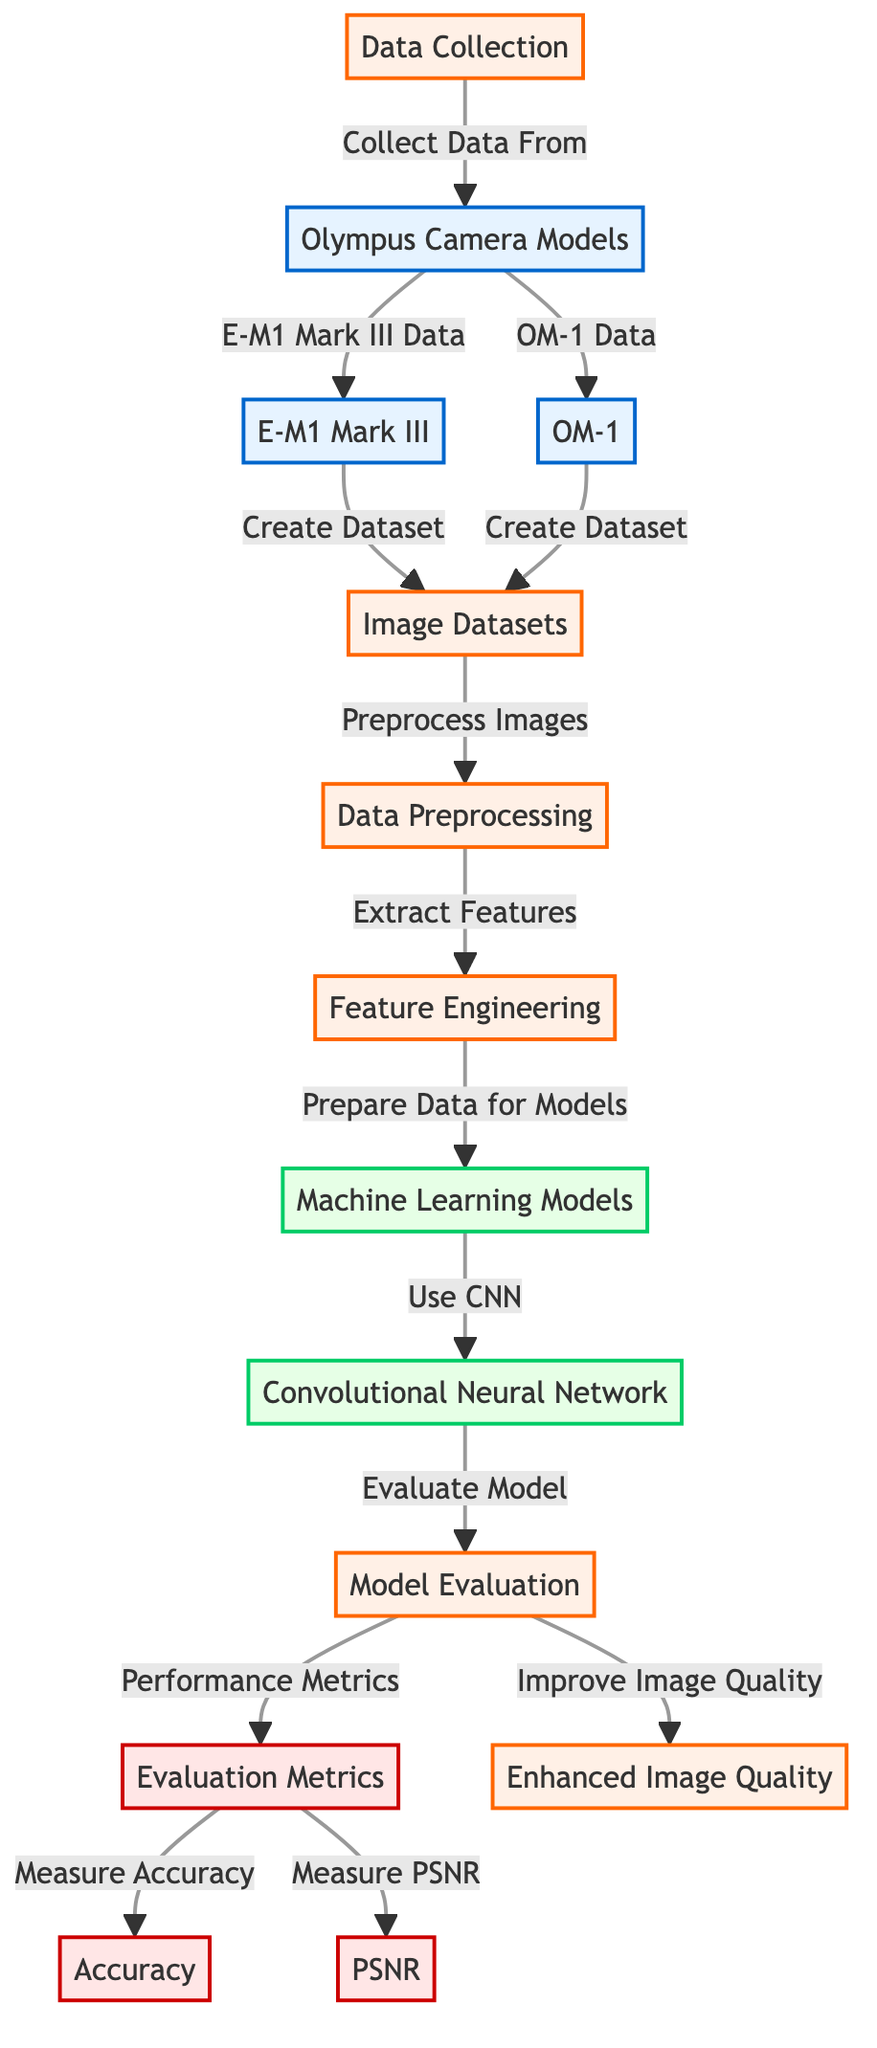What are the two Olympus camera models used in this analysis? The diagram explicitly lists "E-M1 Mark III" and "OM-1" under the "Olympus Camera Models" node.
Answer: E-M1 Mark III, OM-1 What is the first step in the process of the diagram? The first node listed in the process is "Data Collection," indicating that data is to be collected before any other process can take place.
Answer: Data Collection How many evaluation metrics are used in the model evaluation stage? The diagram shows two metrics: "Accuracy" and "PSNR" under the "Evaluation Metrics" node, indicating that these metrics are used to evaluate the model's performance.
Answer: Two What is the direct relationship between "Image Datasets" and "Data Preprocessing"? "Image Datasets" connects to "Data Preprocessing," indicating that the images collected from the various camera models are then subjected to preprocessing activities.
Answer: Preprocess Images Which machine learning technique is utilized for the analysis? The diagram specifies "Convolutional Neural Network" (CNN) as the technique being used in the machine learning models section, indicating the focus on this particular approach.
Answer: Convolutional Neural Network How does the "Model Evaluation" contribute to the output? The diagram illustrates that after evaluation, the performance metrics are used to inform improvements that result in "Enhanced Image Quality," showing how evaluation is pivotal to achieving better quality images.
Answer: Improve Image Quality What type of flow does the diagram represent? The diagram represents a directed flow showing the sequential steps required in the machine learning process from data collection to producing enhanced images, emphasizing the structured and linear approach to the analysis.
Answer: Directed Flow What process follows the "Feature Engineering" in the diagram? The diagram indicates that "Data Preparation for Models" directly follows "Feature Engineering," signifying the next logical step after features have been extracted from the data.
Answer: Prepare Data for Models What happens after the "Use CNN" step? The diagram suggests that following the application of the convolutional neural network, the next step is "Evaluate Model," demonstrating a typical progression from model building to assessing its performance.
Answer: Evaluate Model 